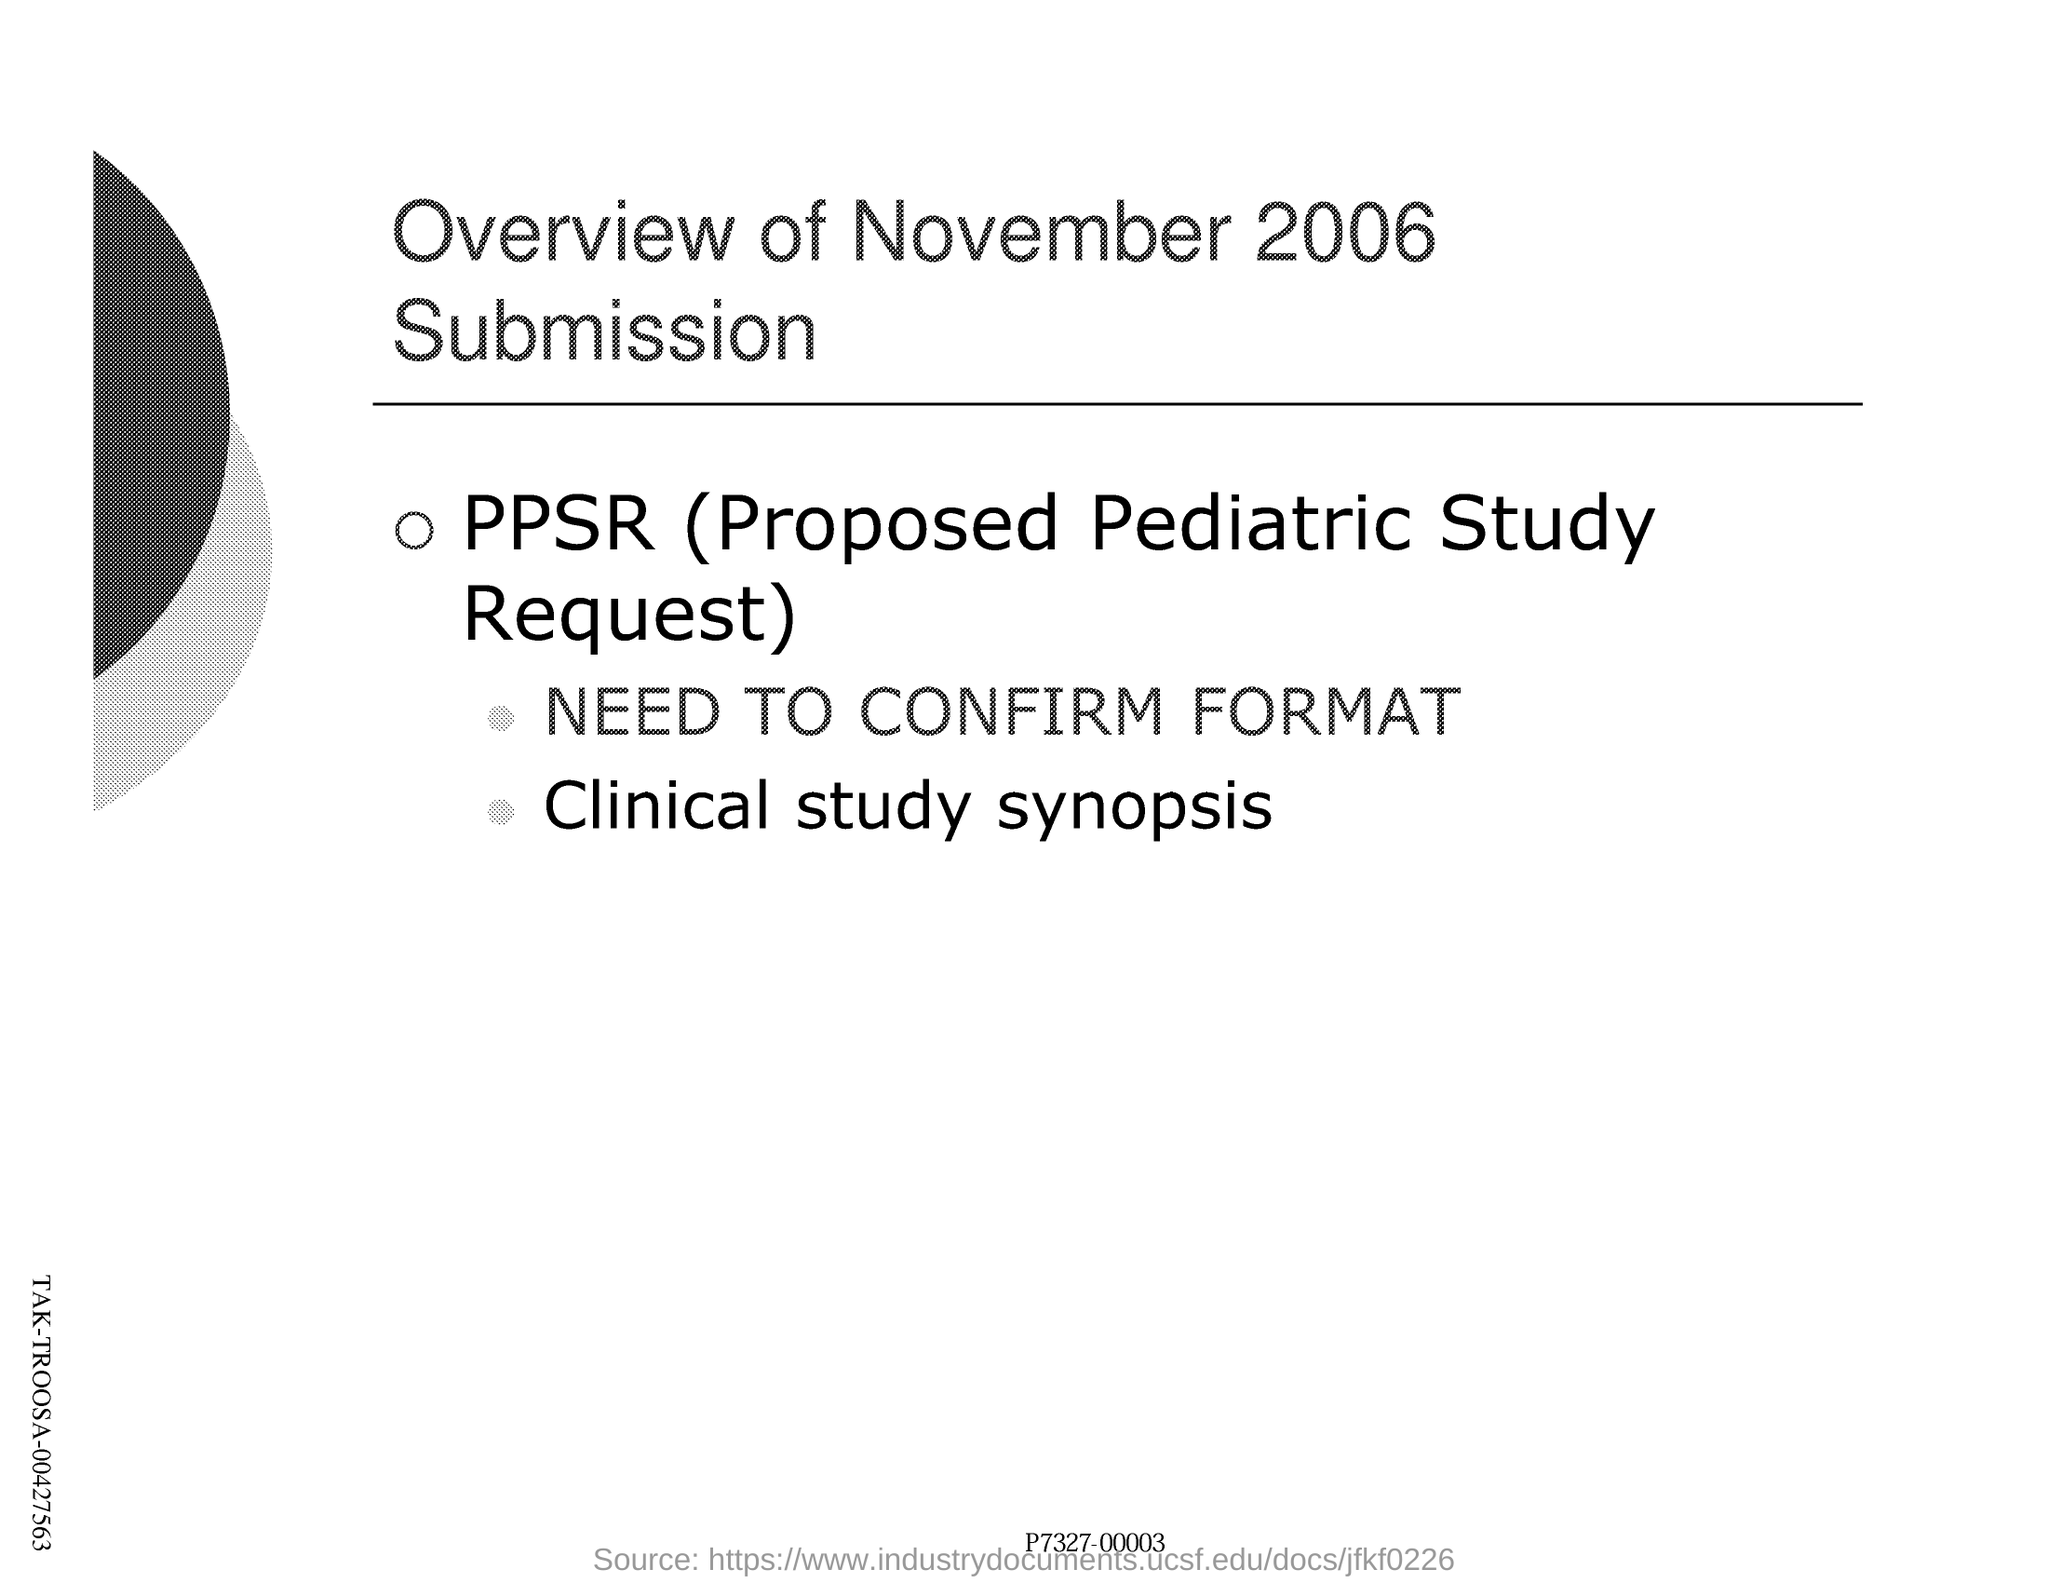List a handful of essential elements in this visual. This document is titled 'Overview of November 2006 Submission.' The full form of PPSR is the Proposed Pediatric Study Request, which is a formal proposal for conducting a study related to pediatrics. 